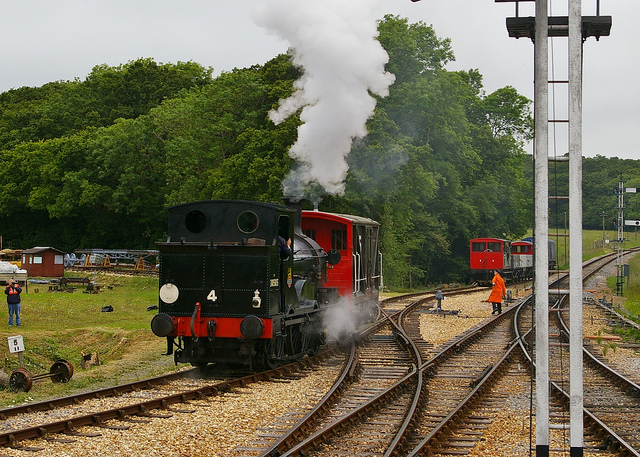Identify and read out the text in this image. 5 11 4 